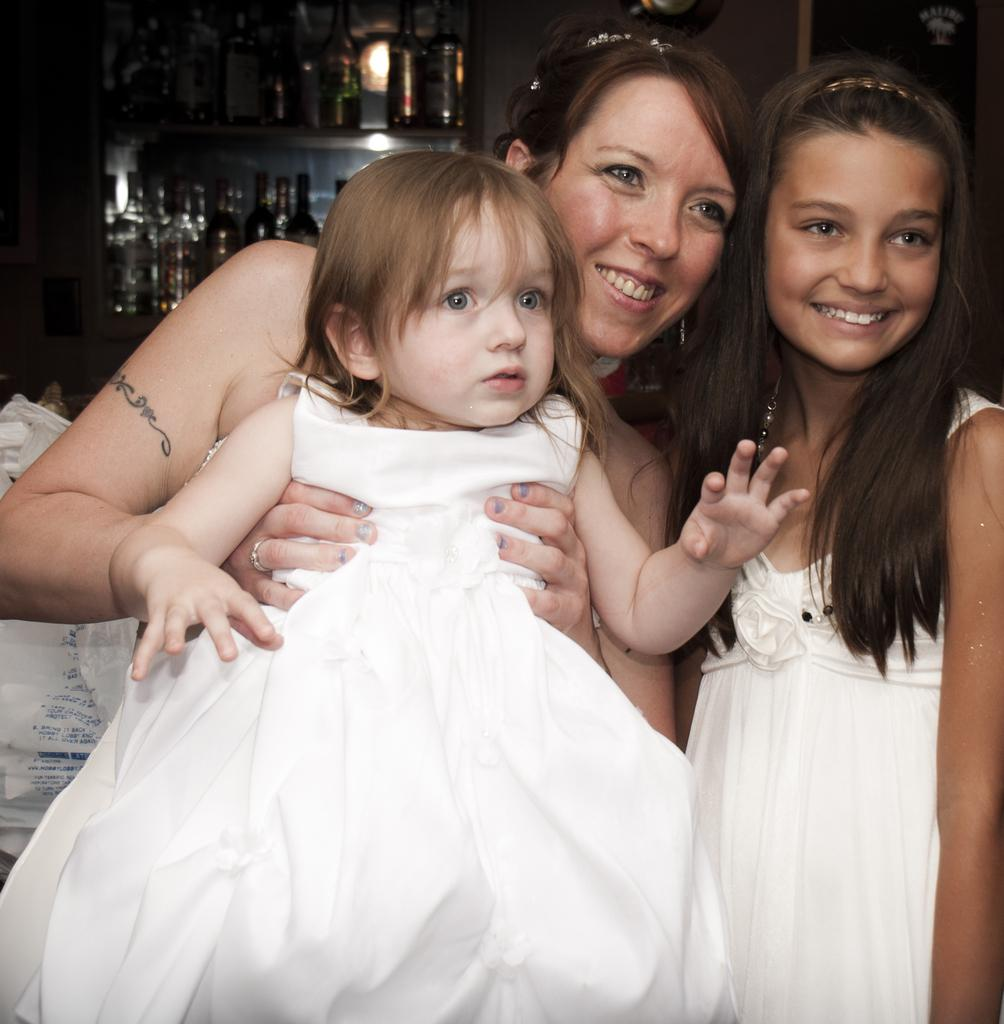Who is the main subject in the image? There is a lady in the image. What is the lady doing in the image? The lady is holding a child. Are there any other children in the image? Yes, there is another child near the lady. What can be seen in the background of the image? There are bottles in the background of the image. What might be used to cover something in the image? There is a cover in the image. What type of wave can be seen crashing on the shore in the image? There is no wave or shore present in the image; it features a lady holding a child with another child nearby. 